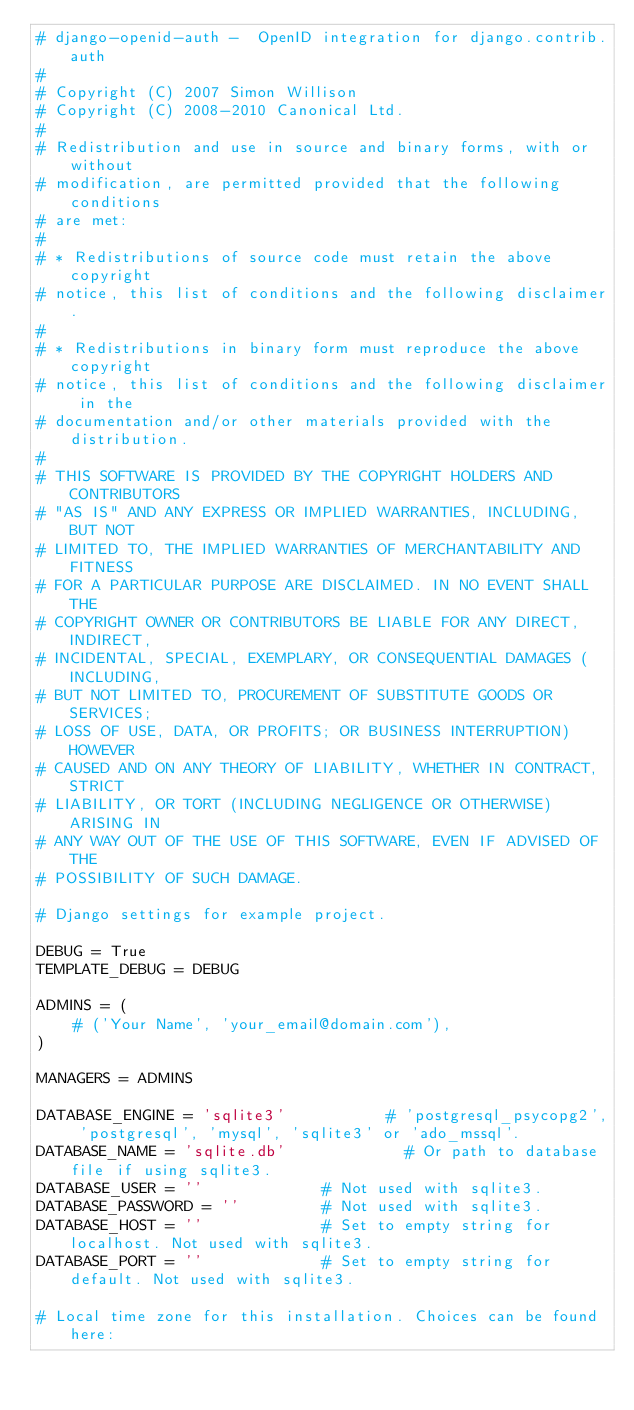<code> <loc_0><loc_0><loc_500><loc_500><_Python_># django-openid-auth -  OpenID integration for django.contrib.auth
#
# Copyright (C) 2007 Simon Willison
# Copyright (C) 2008-2010 Canonical Ltd.
#
# Redistribution and use in source and binary forms, with or without
# modification, are permitted provided that the following conditions
# are met:
#
# * Redistributions of source code must retain the above copyright
# notice, this list of conditions and the following disclaimer.
#
# * Redistributions in binary form must reproduce the above copyright
# notice, this list of conditions and the following disclaimer in the
# documentation and/or other materials provided with the distribution.
#
# THIS SOFTWARE IS PROVIDED BY THE COPYRIGHT HOLDERS AND CONTRIBUTORS
# "AS IS" AND ANY EXPRESS OR IMPLIED WARRANTIES, INCLUDING, BUT NOT
# LIMITED TO, THE IMPLIED WARRANTIES OF MERCHANTABILITY AND FITNESS
# FOR A PARTICULAR PURPOSE ARE DISCLAIMED. IN NO EVENT SHALL THE
# COPYRIGHT OWNER OR CONTRIBUTORS BE LIABLE FOR ANY DIRECT, INDIRECT,
# INCIDENTAL, SPECIAL, EXEMPLARY, OR CONSEQUENTIAL DAMAGES (INCLUDING,
# BUT NOT LIMITED TO, PROCUREMENT OF SUBSTITUTE GOODS OR SERVICES;
# LOSS OF USE, DATA, OR PROFITS; OR BUSINESS INTERRUPTION) HOWEVER
# CAUSED AND ON ANY THEORY OF LIABILITY, WHETHER IN CONTRACT, STRICT
# LIABILITY, OR TORT (INCLUDING NEGLIGENCE OR OTHERWISE) ARISING IN
# ANY WAY OUT OF THE USE OF THIS SOFTWARE, EVEN IF ADVISED OF THE
# POSSIBILITY OF SUCH DAMAGE.

# Django settings for example project.

DEBUG = True
TEMPLATE_DEBUG = DEBUG

ADMINS = (
    # ('Your Name', 'your_email@domain.com'),
)

MANAGERS = ADMINS

DATABASE_ENGINE = 'sqlite3'           # 'postgresql_psycopg2', 'postgresql', 'mysql', 'sqlite3' or 'ado_mssql'.
DATABASE_NAME = 'sqlite.db'             # Or path to database file if using sqlite3.
DATABASE_USER = ''             # Not used with sqlite3.
DATABASE_PASSWORD = ''         # Not used with sqlite3.
DATABASE_HOST = ''             # Set to empty string for localhost. Not used with sqlite3.
DATABASE_PORT = ''             # Set to empty string for default. Not used with sqlite3.

# Local time zone for this installation. Choices can be found here:</code> 